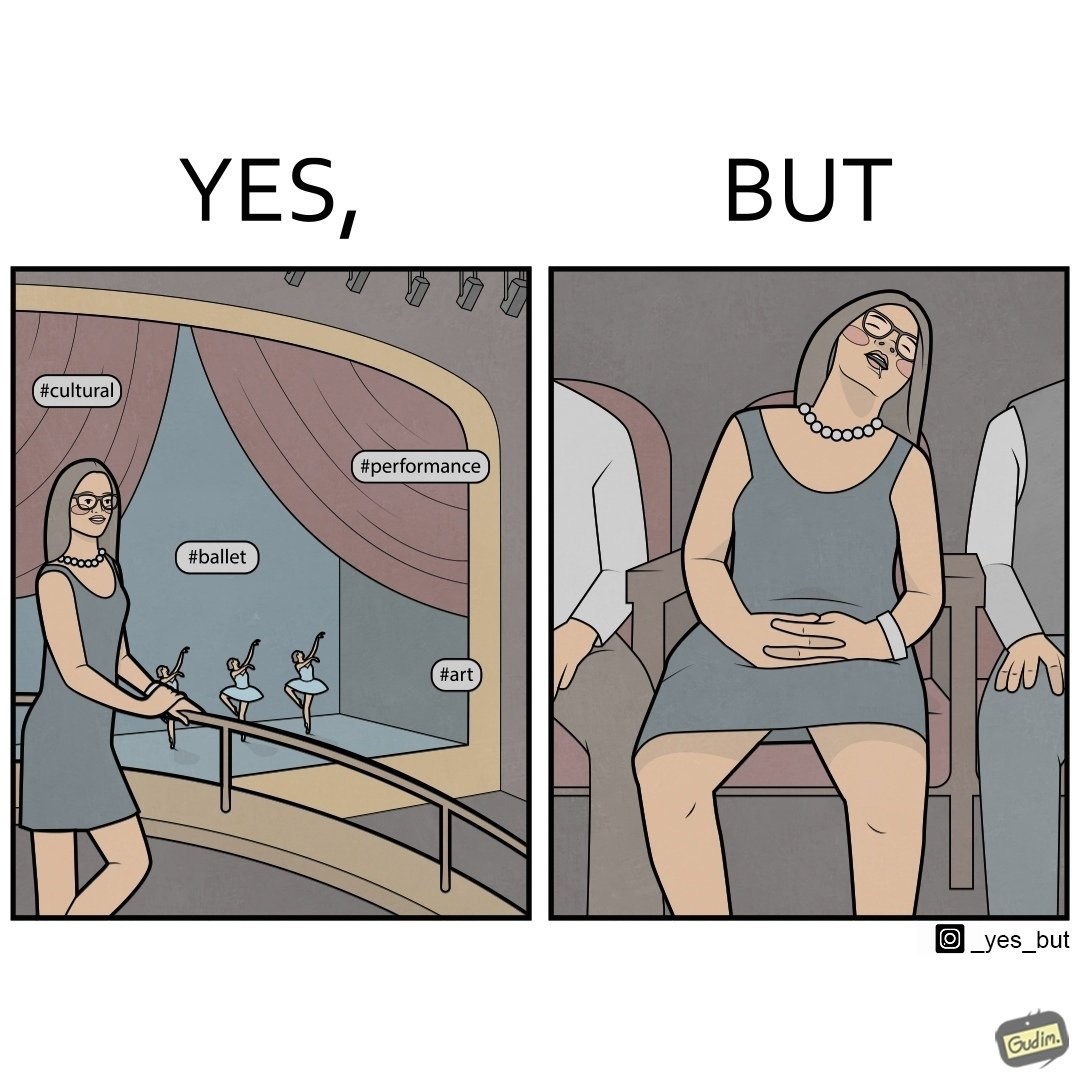Does this image contain satire or humor? Yes, this image is satirical. 